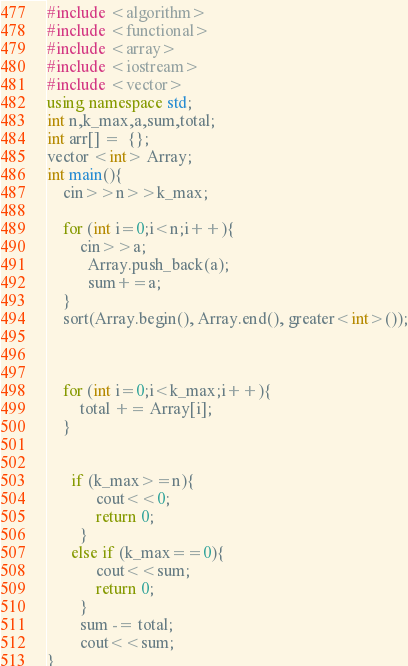Convert code to text. <code><loc_0><loc_0><loc_500><loc_500><_C++_>#include <algorithm>
#include <functional>
#include <array>
#include <iostream>
#include <vector>
using namespace std;
int n,k_max,a,sum,total;
int arr[] =  {};
vector <int> Array;
int main(){
    cin>>n>>k_max;
      
    for (int i=0;i<n;i++){
        cin>>a;
          Array.push_back(a);
          sum+=a;
    }
    sort(Array.begin(), Array.end(), greater<int>());
   
    
          
    for (int i=0;i<k_max;i++){
        total += Array[i];
    }
   
        
      if (k_max>=n){
            cout<<0;
            return 0;
        }
      else if (k_max==0){
            cout<<sum;
            return 0;
        }
        sum -= total;
        cout<<sum;
}
</code> 